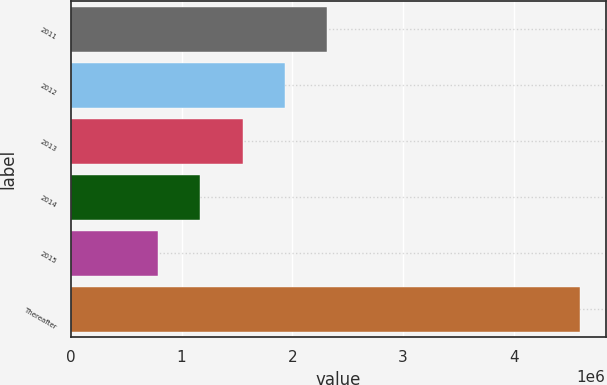Convert chart to OTSL. <chart><loc_0><loc_0><loc_500><loc_500><bar_chart><fcel>2011<fcel>2012<fcel>2013<fcel>2014<fcel>2015<fcel>Thereafter<nl><fcel>2.31404e+06<fcel>1.93288e+06<fcel>1.55172e+06<fcel>1.17056e+06<fcel>789405<fcel>4.601e+06<nl></chart> 